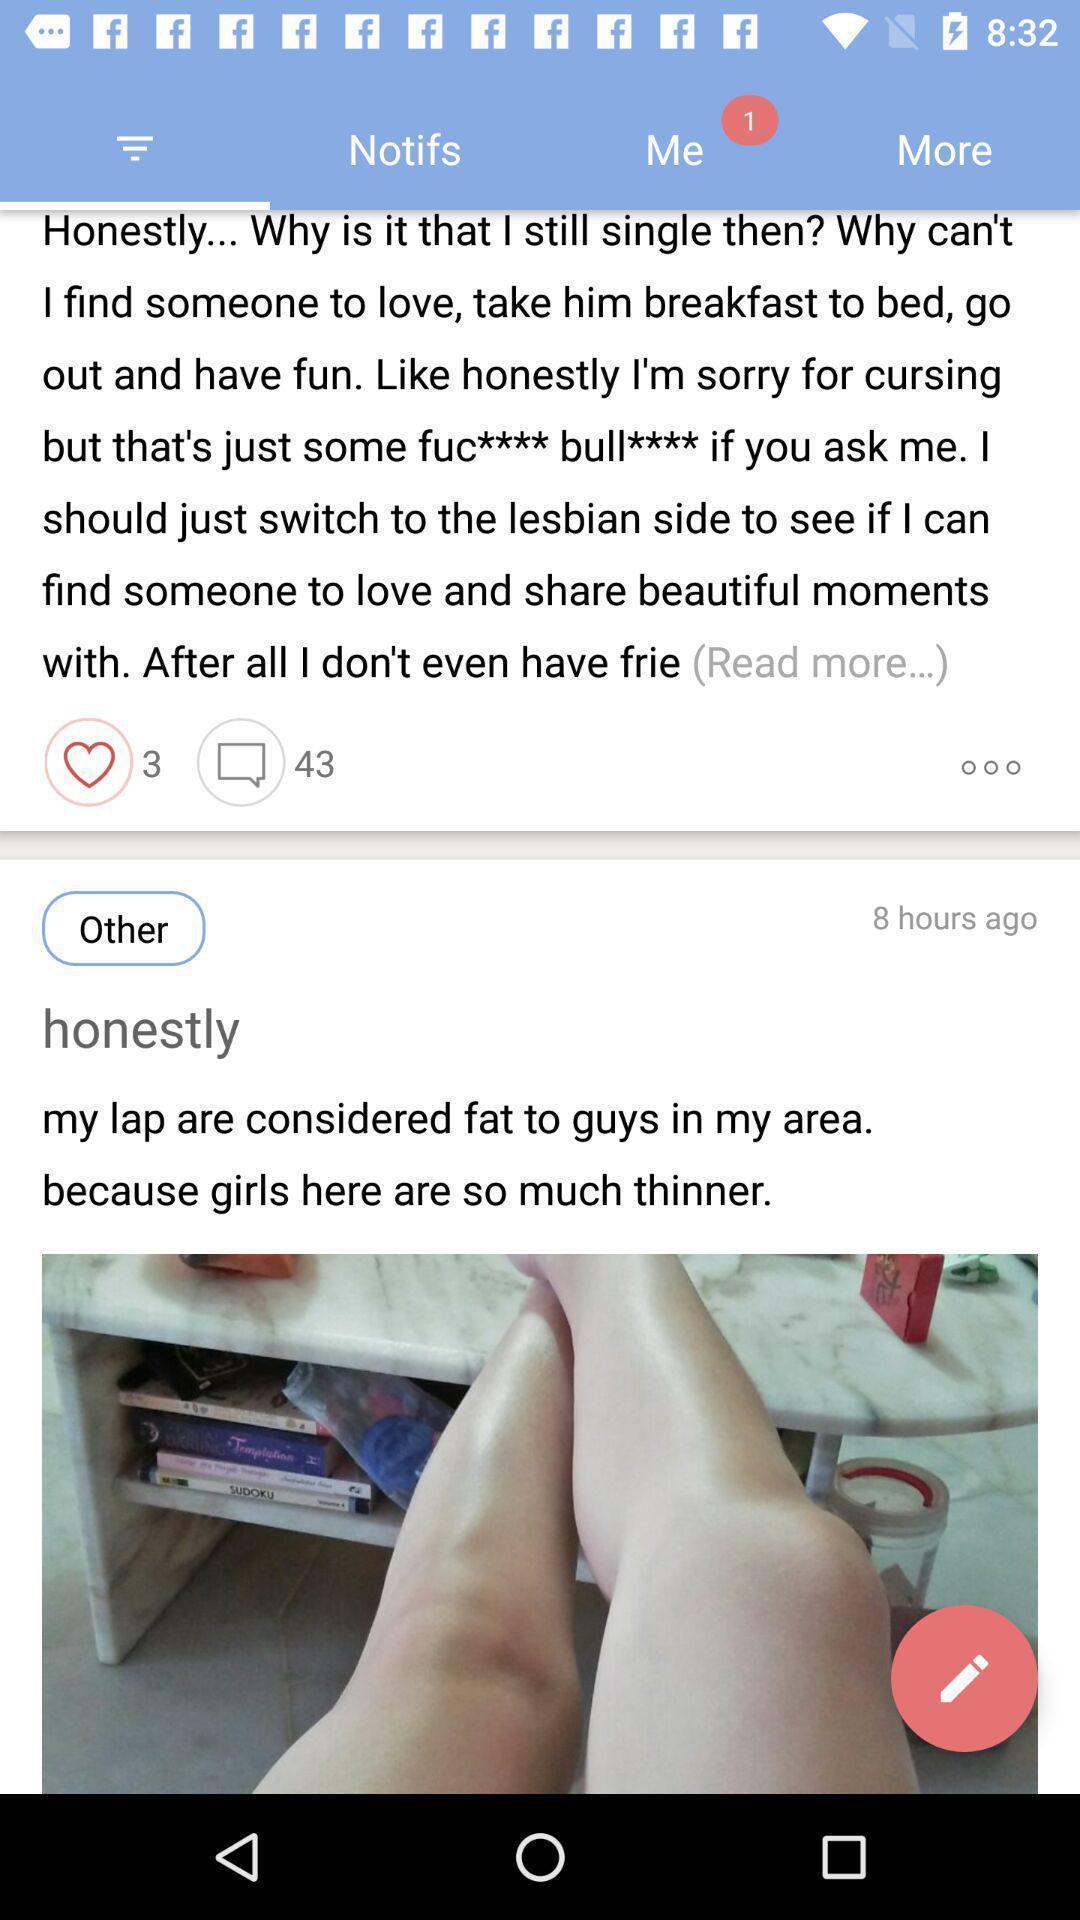Give me a summary of this screen capture. Screen displaying posts by different users on social app. 